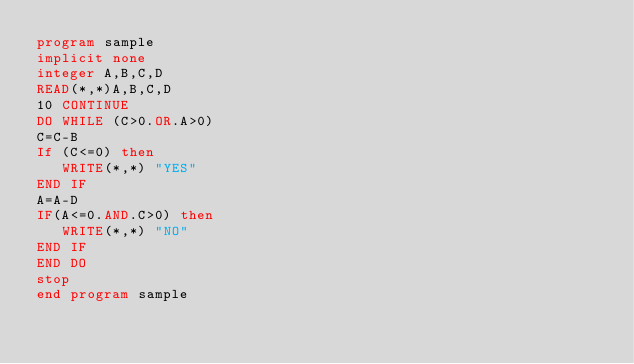<code> <loc_0><loc_0><loc_500><loc_500><_FORTRAN_>program sample
implicit none
integer A,B,C,D
READ(*,*)A,B,C,D
10 CONTINUE
DO WHILE (C>0.OR.A>0)
C=C-B
If (C<=0) then
   WRITE(*,*) "YES"
END IF
A=A-D
IF(A<=0.AND.C>0) then
   WRITE(*,*) "NO"
END IF
END DO
stop
end program sample


</code> 